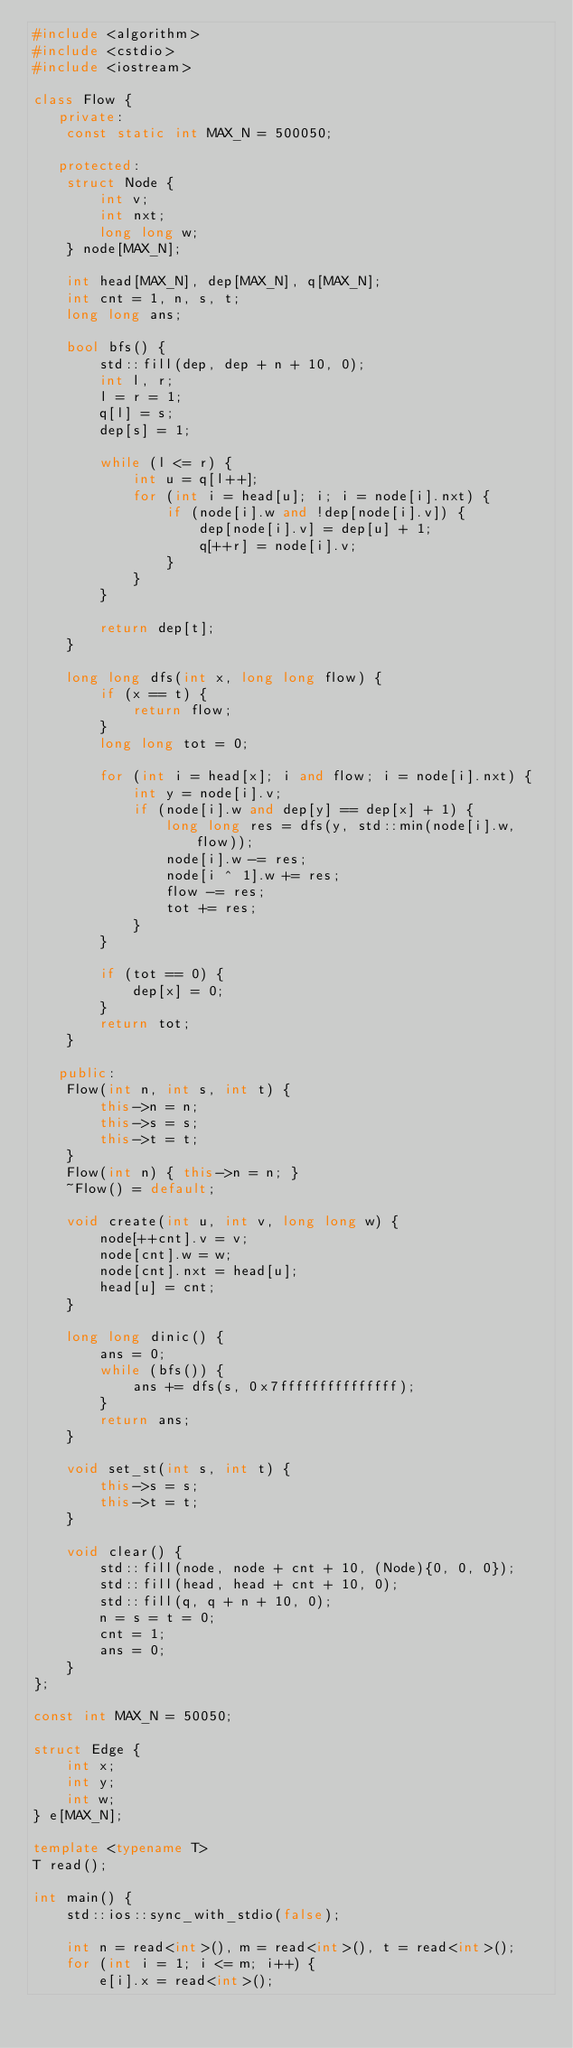Convert code to text. <code><loc_0><loc_0><loc_500><loc_500><_C++_>#include <algorithm>
#include <cstdio>
#include <iostream>

class Flow {
   private:
    const static int MAX_N = 500050;

   protected:
    struct Node {
        int v;
        int nxt;
        long long w;
    } node[MAX_N];

    int head[MAX_N], dep[MAX_N], q[MAX_N];
    int cnt = 1, n, s, t;
    long long ans;

    bool bfs() {
        std::fill(dep, dep + n + 10, 0);
        int l, r;
        l = r = 1;
        q[l] = s;
        dep[s] = 1;

        while (l <= r) {
            int u = q[l++];
            for (int i = head[u]; i; i = node[i].nxt) {
                if (node[i].w and !dep[node[i].v]) {
                    dep[node[i].v] = dep[u] + 1;
                    q[++r] = node[i].v;
                }
            }
        }

        return dep[t];
    }

    long long dfs(int x, long long flow) {
        if (x == t) {
            return flow;
        }
        long long tot = 0;

        for (int i = head[x]; i and flow; i = node[i].nxt) {
            int y = node[i].v;
            if (node[i].w and dep[y] == dep[x] + 1) {
                long long res = dfs(y, std::min(node[i].w, flow));
                node[i].w -= res;
                node[i ^ 1].w += res;
                flow -= res;
                tot += res;
            }
        }

        if (tot == 0) {
            dep[x] = 0;
        }
        return tot;
    }

   public:
    Flow(int n, int s, int t) {
        this->n = n;
        this->s = s;
        this->t = t;
    }
    Flow(int n) { this->n = n; }
    ~Flow() = default;

    void create(int u, int v, long long w) {
        node[++cnt].v = v;
        node[cnt].w = w;
        node[cnt].nxt = head[u];
        head[u] = cnt;
    }

    long long dinic() {
        ans = 0;
        while (bfs()) {
            ans += dfs(s, 0x7fffffffffffffff);
        }
        return ans;
    }

    void set_st(int s, int t) {
        this->s = s;
        this->t = t;
    }

    void clear() {
        std::fill(node, node + cnt + 10, (Node){0, 0, 0});
        std::fill(head, head + cnt + 10, 0);
        std::fill(q, q + n + 10, 0);
        n = s = t = 0;
        cnt = 1;
        ans = 0;
    }
};

const int MAX_N = 50050;

struct Edge {
    int x;
    int y;
    int w;
} e[MAX_N];

template <typename T>
T read();

int main() {
    std::ios::sync_with_stdio(false);

    int n = read<int>(), m = read<int>(), t = read<int>();
    for (int i = 1; i <= m; i++) {
        e[i].x = read<int>();</code> 